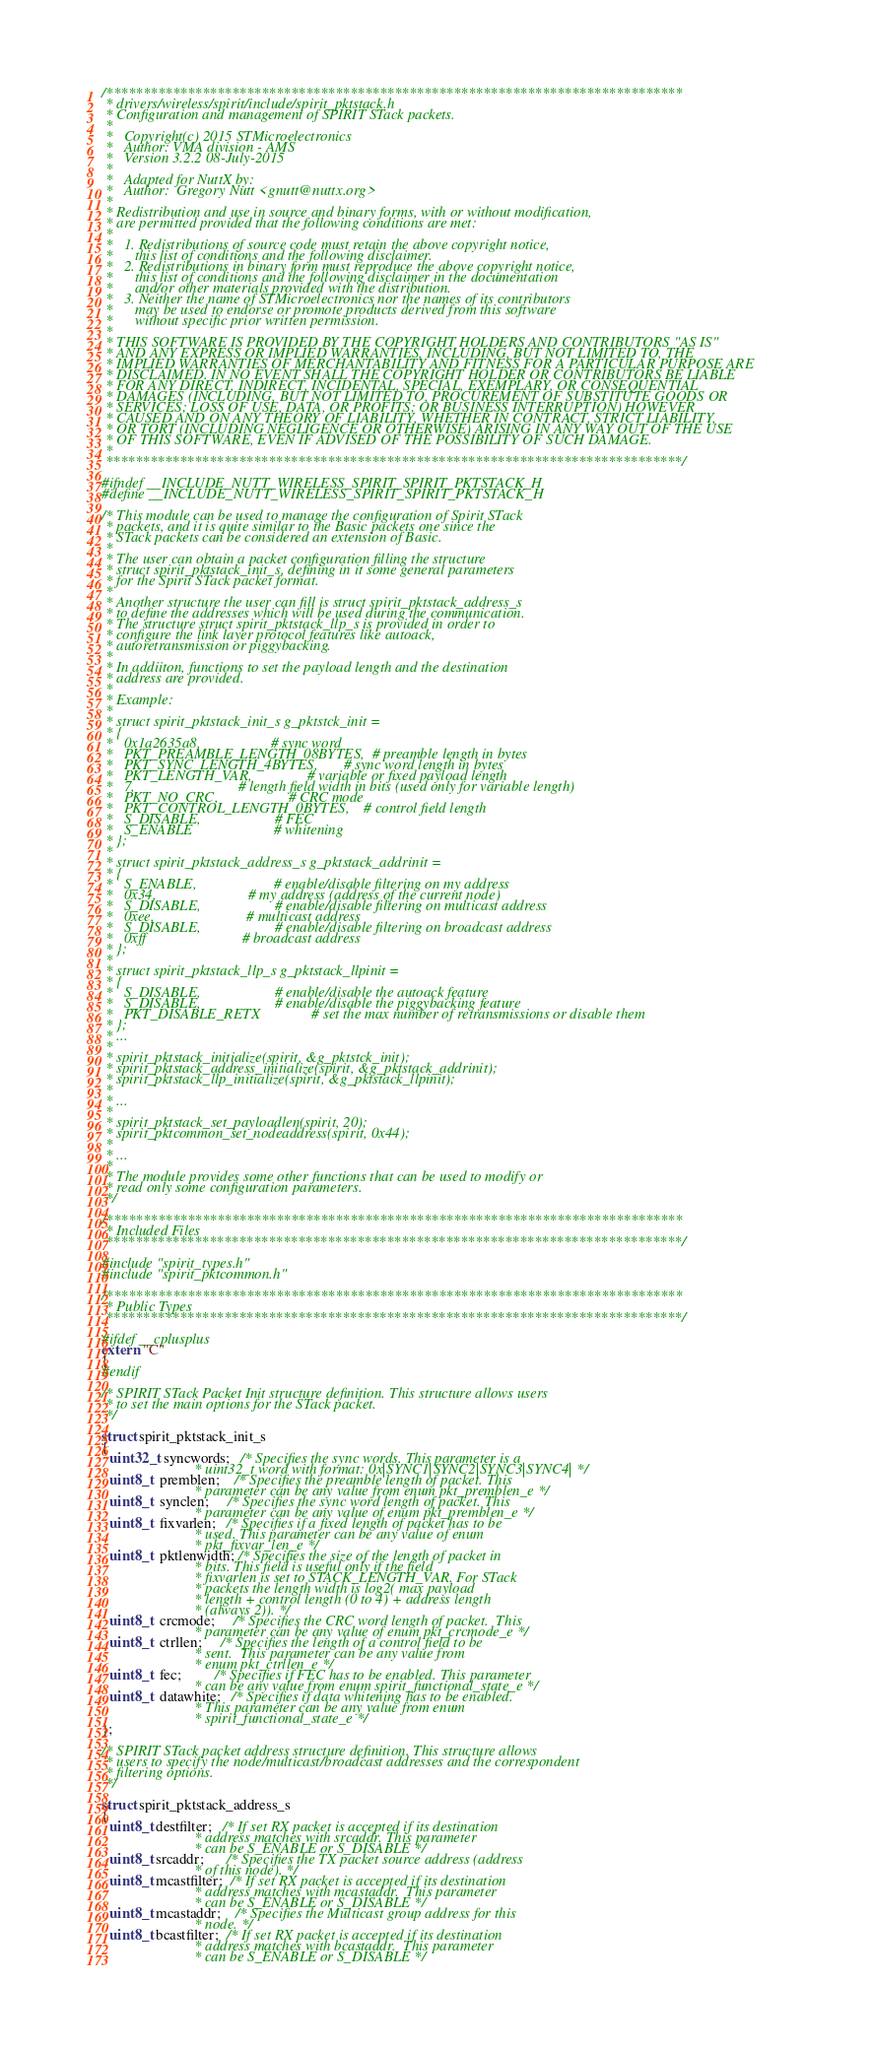Convert code to text. <code><loc_0><loc_0><loc_500><loc_500><_C_>/******************************************************************************
 * drivers/wireless/spirit/include/spirit_pktstack.h
 * Configuration and management of SPIRIT STack packets.
 *
 *   Copyright(c) 2015 STMicroelectronics
 *   Author: VMA division - AMS
 *   Version 3.2.2 08-July-2015
 *
 *   Adapted for NuttX by:
 *   Author:  Gregory Nutt <gnutt@nuttx.org>
 *
 * Redistribution and use in source and binary forms, with or without modification,
 * are permitted provided that the following conditions are met:
 *
 *   1. Redistributions of source code must retain the above copyright notice,
 *      this list of conditions and the following disclaimer.
 *   2. Redistributions in binary form must reproduce the above copyright notice,
 *      this list of conditions and the following disclaimer in the documentation
 *      and/or other materials provided with the distribution.
 *   3. Neither the name of STMicroelectronics nor the names of its contributors
 *      may be used to endorse or promote products derived from this software
 *      without specific prior written permission.
 *
 * THIS SOFTWARE IS PROVIDED BY THE COPYRIGHT HOLDERS AND CONTRIBUTORS "AS IS"
 * AND ANY EXPRESS OR IMPLIED WARRANTIES, INCLUDING, BUT NOT LIMITED TO, THE
 * IMPLIED WARRANTIES OF MERCHANTABILITY AND FITNESS FOR A PARTICULAR PURPOSE ARE
 * DISCLAIMED. IN NO EVENT SHALL THE COPYRIGHT HOLDER OR CONTRIBUTORS BE LIABLE
 * FOR ANY DIRECT, INDIRECT, INCIDENTAL, SPECIAL, EXEMPLARY, OR CONSEQUENTIAL
 * DAMAGES (INCLUDING, BUT NOT LIMITED TO, PROCUREMENT OF SUBSTITUTE GOODS OR
 * SERVICES; LOSS OF USE, DATA, OR PROFITS; OR BUSINESS INTERRUPTION) HOWEVER
 * CAUSED AND ON ANY THEORY OF LIABILITY, WHETHER IN CONTRACT, STRICT LIABILITY,
 * OR TORT (INCLUDING NEGLIGENCE OR OTHERWISE) ARISING IN ANY WAY OUT OF THE USE
 * OF THIS SOFTWARE, EVEN IF ADVISED OF THE POSSIBILITY OF SUCH DAMAGE.
 *
 ******************************************************************************/

#ifndef __INCLUDE_NUTT_WIRELESS_SPIRIT_SPIRIT_PKTSTACK_H
#define __INCLUDE_NUTT_WIRELESS_SPIRIT_SPIRIT_PKTSTACK_H

/* This module can be used to manage the configuration of Spirit STack
 * packets, and it is quite similar to the Basic packets one since the
 * STack packets can be considered an extension of Basic.
 *
 * The user can obtain a packet configuration filling the structure
 * struct spirit_pktstack_init_s, defining in it some general parameters
 * for the Spirit STack packet format.
 *
 * Another structure the user can fill is struct spirit_pktstack_address_s
 * to define the addresses which will be used during the communication.
 * The structure struct spirit_pktstack_llp_s is provided in order to
 * configure the link layer protocol features like autoack,
 * autoretransmission or piggybacking.
 *
 * In addiiton, functions to set the payload length and the destination
 * address are provided.
 *
 * Example:
 *
 * struct spirit_pktstack_init_s g_pktstck_init =
 * {
 *   0x1a2635a8,                   # sync word
 *   PKT_PREAMBLE_LENGTH_08BYTES,  # preamble length in bytes
 *   PKT_SYNC_LENGTH_4BYTES,       # sync word length in bytes
 *   PKT_LENGTH_VAR,               # variable or fixed payload length
 *   7,                            # length field width in bits (used only for variable length)
 *   PKT_NO_CRC,                   # CRC mode
 *   PKT_CONTROL_LENGTH_0BYTES,    # control field length
 *   S_DISABLE,                    # FEC
 *   S_ENABLE                      # whitening
 * };
 *
 * struct spirit_pktstack_address_s g_pktstack_addrinit =
 * {
 *   S_ENABLE,                     # enable/disable filtering on my address
 *   0x34,                         # my address (address of the current node)
 *   S_DISABLE,                    # enable/disable filtering on multicast address
 *   0xee,                         # multicast address
 *   S_DISABLE,                    # enable/disable filtering on broadcast address
 *   0xff                          # broadcast address
 * };
 *
 * struct spirit_pktstack_llp_s g_pktstack_llpinit =
 * {
 *   S_DISABLE,                    # enable/disable the autoack feature
 *   S_DISABLE,                    # enable/disable the piggybacking feature
 *   PKT_DISABLE_RETX              # set the max number of retransmissions or disable them
 * };
 * ...
 *
 * spirit_pktstack_initialize(spirit, &g_pktstck_init);
 * spirit_pktstack_address_initialize(spirit, &g_pktstack_addrinit);
 * spirit_pktstack_llp_initialize(spirit, &g_pktstack_llpinit);
 *
 * ...
 *
 * spirit_pktstack_set_payloadlen(spirit, 20);
 * spirit_pktcommon_set_nodeaddress(spirit, 0x44);
 *
 * ...
 *
 * The module provides some other functions that can be used to modify or
 * read only some configuration parameters.
 */

/******************************************************************************
 * Included Files
 ******************************************************************************/

#include "spirit_types.h"
#include "spirit_pktcommon.h"

/******************************************************************************
 * Public Types
 ******************************************************************************/

#ifdef __cplusplus
extern "C"
{
#endif

/* SPIRIT STack Packet Init structure definition. This structure allows users
 * to set the main options for the STack packet.
 */

struct spirit_pktstack_init_s
{
  uint32_t syncwords;   /* Specifies the sync words. This parameter is a
                         * uint32_t word with format: 0x|SYNC1|SYNC2|SYNC3|SYNC4| */
  uint8_t  premblen;    /* Specifies the preamble length of packet. This
                         * parameter can be any value from enum pkt_premblen_e */
  uint8_t  synclen;     /* Specifies the sync word length of packet. This
                         * parameter can be any value of enum pkt_premblen_e */
  uint8_t  fixvarlen;   /* Specifies if a fixed length of packet has to be
                         * used. This parameter can be any value of enum
                         * pkt_fixvar_len_e */
  uint8_t  pktlenwidth; /* Specifies the size of the length of packet in
                         * bits. This field is useful only if the field
                         * fixvarlen is set to STACK_LENGTH_VAR. For STack
                         * packets the length width is log2( max payload
                         * length + control length (0 to 4) + address length
                         * (always 2)). */
  uint8_t  crcmode;     /* Specifies the CRC word length of packet.  This
                         * parameter can be any value of enum pkt_crcmode_e */
  uint8_t  ctrllen;     /* Specifies the length of a control field to be
                         * sent.  This parameter can be any value from
                         * enum pkt_ctrllen_e */
  uint8_t  fec;         /* Specifies if FEC has to be enabled. This parameter
                         * can be any value from enum spirit_functional_state_e */
  uint8_t  datawhite;   /* Specifies if data whitening has to be enabled.
                         * This parameter can be any value from enum
                         * spirit_functional_state_e */
};

/* SPIRIT STack packet address structure definition. This structure allows
 * users to specify the node/multicast/broadcast addresses and the correspondent
 * filtering options.
 */

struct spirit_pktstack_address_s
{
  uint8_t destfilter;   /* If set RX packet is accepted if its destination
                         * address matches with srcaddr. This parameter
                         * can be S_ENABLE or S_DISABLE */
  uint8_t srcaddr;      /* Specifies the TX packet source address (address
                         * of this node). */
  uint8_t mcastfilter;  /* If set RX packet is accepted if its destination
                         * address matches with mcastaddr.  This parameter
                         * can be S_ENABLE or S_DISABLE */
  uint8_t mcastaddr;    /* Specifies the Multicast group address for this
                         * node. */
  uint8_t bcastfilter;  /* If set RX packet is accepted if its destination
                         * address matches with bcastaddr.  This parameter
                         * can be S_ENABLE or S_DISABLE */</code> 